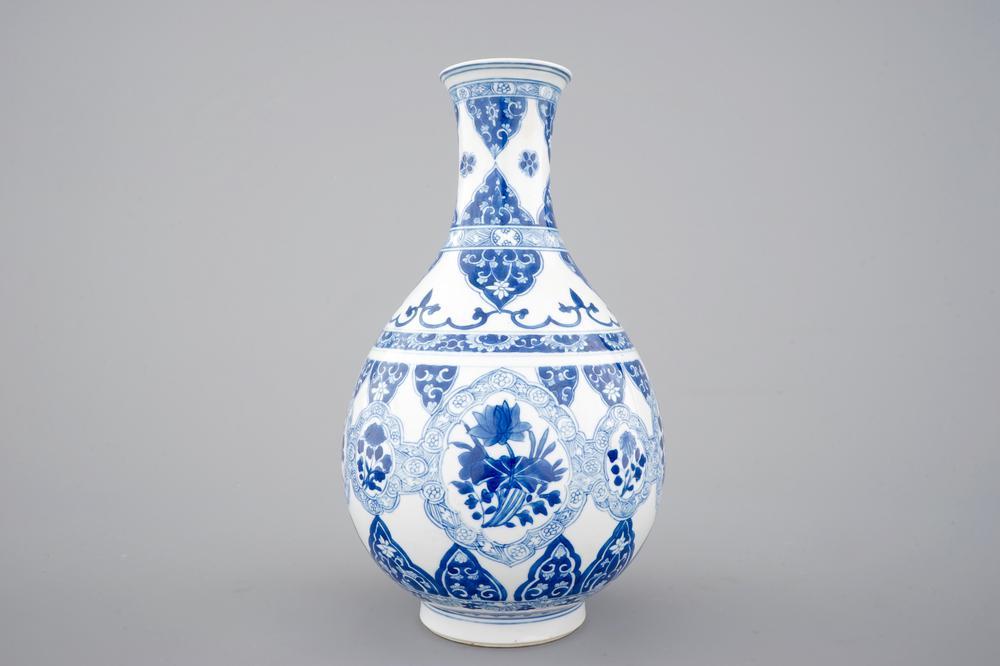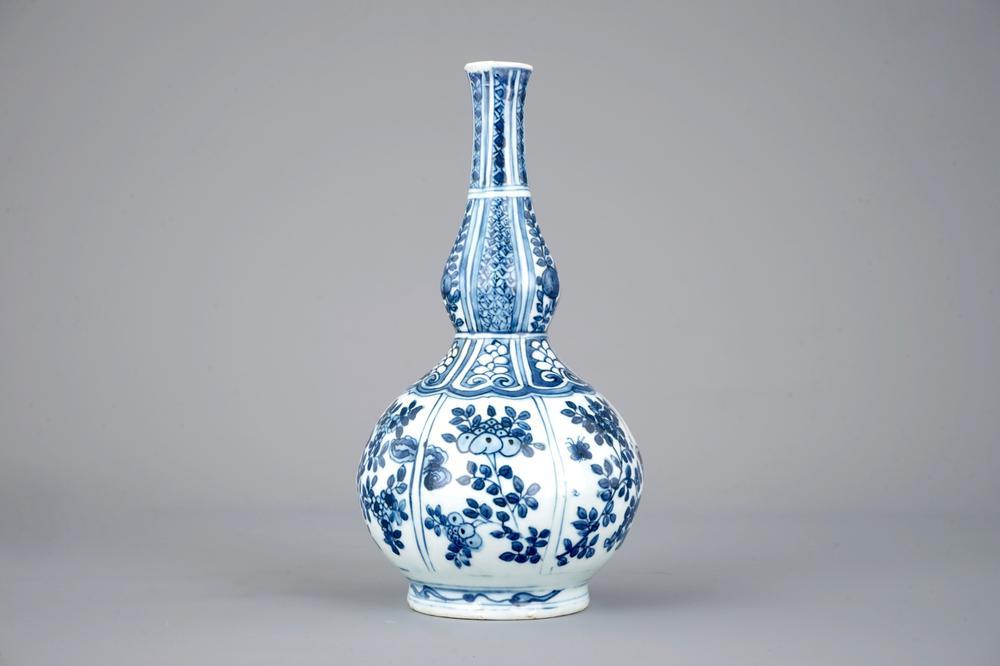The first image is the image on the left, the second image is the image on the right. Assess this claim about the two images: "The vases in the left and right images do not have the same shape, and at least one vase features a dragon-like creature on it.". Correct or not? Answer yes or no. No. The first image is the image on the left, the second image is the image on the right. For the images shown, is this caption "One vase has a bulge in the stem." true? Answer yes or no. Yes. 